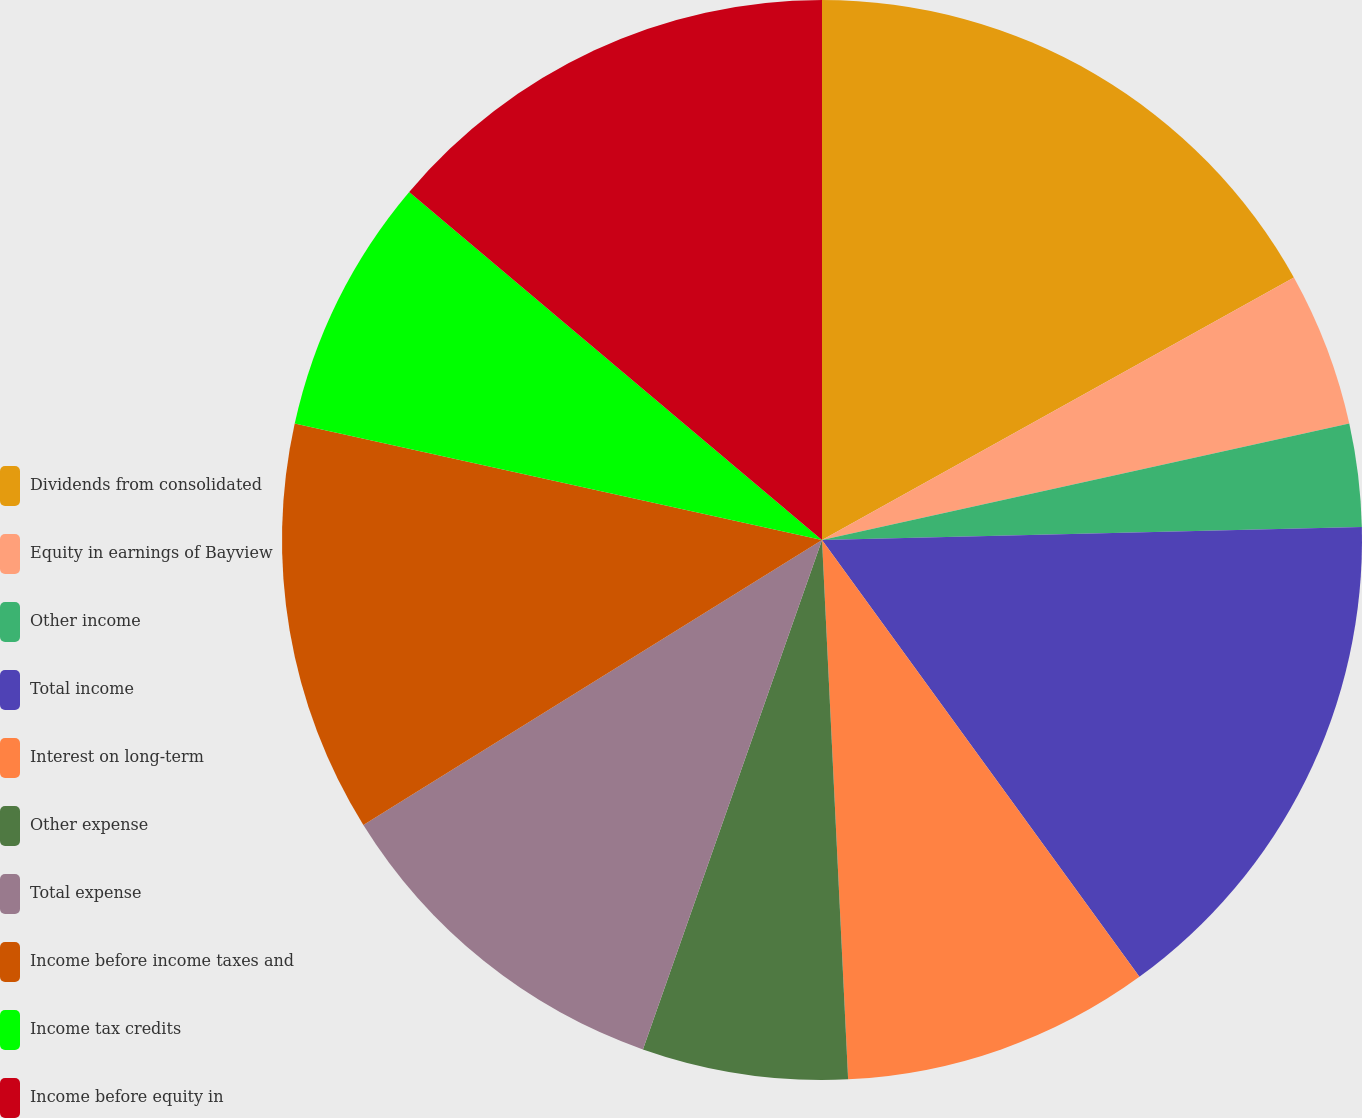Convert chart to OTSL. <chart><loc_0><loc_0><loc_500><loc_500><pie_chart><fcel>Dividends from consolidated<fcel>Equity in earnings of Bayview<fcel>Other income<fcel>Total income<fcel>Interest on long-term<fcel>Other expense<fcel>Total expense<fcel>Income before income taxes and<fcel>Income tax credits<fcel>Income before equity in<nl><fcel>16.92%<fcel>4.62%<fcel>3.08%<fcel>15.38%<fcel>9.23%<fcel>6.15%<fcel>10.77%<fcel>12.31%<fcel>7.69%<fcel>13.85%<nl></chart> 